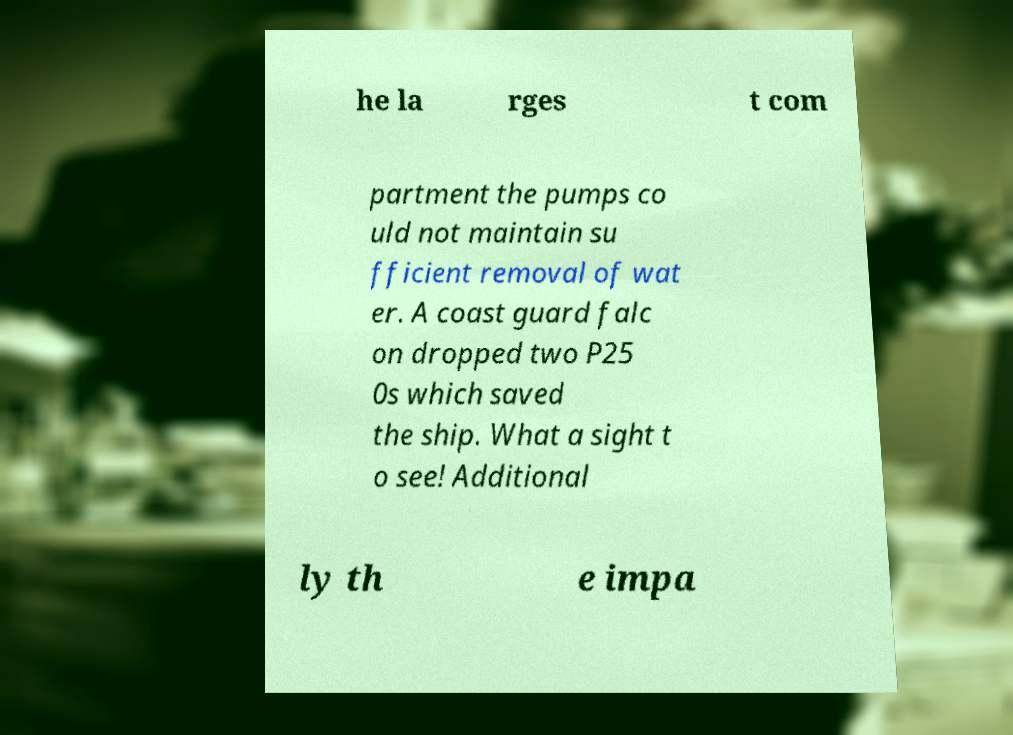What messages or text are displayed in this image? I need them in a readable, typed format. he la rges t com partment the pumps co uld not maintain su fficient removal of wat er. A coast guard falc on dropped two P25 0s which saved the ship. What a sight t o see! Additional ly th e impa 